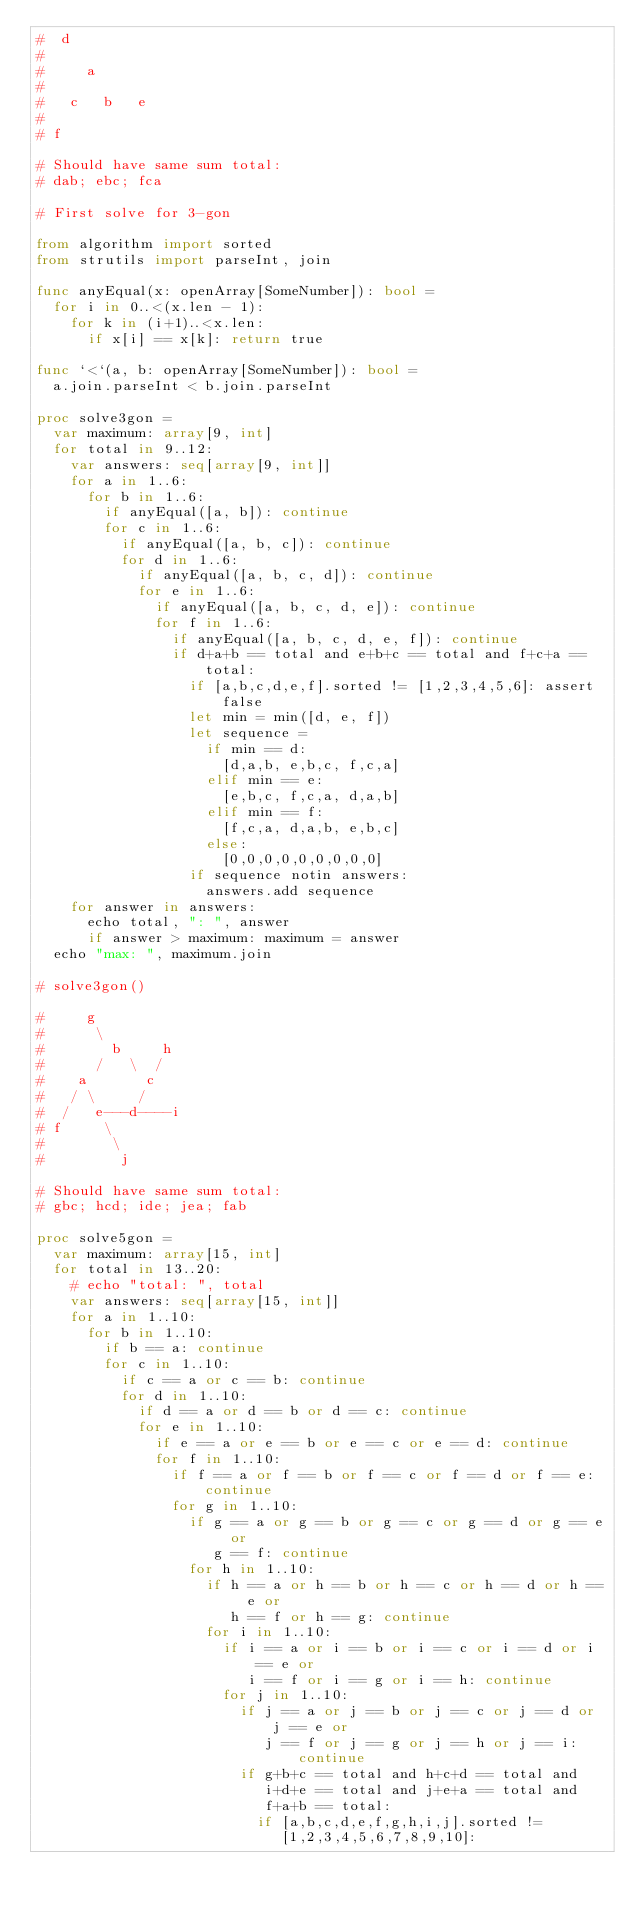<code> <loc_0><loc_0><loc_500><loc_500><_Nim_>#  d
#
#     a
#
#   c   b   e
#
# f

# Should have same sum total:
# dab; ebc; fca

# First solve for 3-gon

from algorithm import sorted
from strutils import parseInt, join

func anyEqual(x: openArray[SomeNumber]): bool =
  for i in 0..<(x.len - 1):
    for k in (i+1)..<x.len:
      if x[i] == x[k]: return true

func `<`(a, b: openArray[SomeNumber]): bool =
  a.join.parseInt < b.join.parseInt

proc solve3gon =
  var maximum: array[9, int]
  for total in 9..12:
    var answers: seq[array[9, int]]
    for a in 1..6:
      for b in 1..6:
        if anyEqual([a, b]): continue
        for c in 1..6:
          if anyEqual([a, b, c]): continue
          for d in 1..6:
            if anyEqual([a, b, c, d]): continue
            for e in 1..6:
              if anyEqual([a, b, c, d, e]): continue
              for f in 1..6:
                if anyEqual([a, b, c, d, e, f]): continue
                if d+a+b == total and e+b+c == total and f+c+a == total:
                  if [a,b,c,d,e,f].sorted != [1,2,3,4,5,6]: assert false
                  let min = min([d, e, f])
                  let sequence =
                    if min == d:
                      [d,a,b, e,b,c, f,c,a]
                    elif min == e:
                      [e,b,c, f,c,a, d,a,b]
                    elif min == f:
                      [f,c,a, d,a,b, e,b,c]
                    else:
                      [0,0,0,0,0,0,0,0,0]
                  if sequence notin answers:
                    answers.add sequence
    for answer in answers:
      echo total, ": ", answer
      if answer > maximum: maximum = answer
  echo "max: ", maximum.join

# solve3gon()

#     g
#      \
#        b     h
#      /   \  /
#    a       c
#   / \     /
#  /   e---d----i
# f     \
#        \
#         j

# Should have same sum total:
# gbc; hcd; ide; jea; fab

proc solve5gon =
  var maximum: array[15, int]
  for total in 13..20:
    # echo "total: ", total
    var answers: seq[array[15, int]]
    for a in 1..10:
      for b in 1..10:
        if b == a: continue
        for c in 1..10:
          if c == a or c == b: continue
          for d in 1..10:
            if d == a or d == b or d == c: continue
            for e in 1..10:
              if e == a or e == b or e == c or e == d: continue
              for f in 1..10:
                if f == a or f == b or f == c or f == d or f == e: continue
                for g in 1..10:
                  if g == a or g == b or g == c or g == d or g == e or
                     g == f: continue
                  for h in 1..10:
                    if h == a or h == b or h == c or h == d or h == e or
                       h == f or h == g: continue
                    for i in 1..10:
                      if i == a or i == b or i == c or i == d or i == e or
                         i == f or i == g or i == h: continue
                      for j in 1..10:
                        if j == a or j == b or j == c or j == d or j == e or
                           j == f or j == g or j == h or j == i: continue
                        if g+b+c == total and h+c+d == total and
                           i+d+e == total and j+e+a == total and
                           f+a+b == total:
                          if [a,b,c,d,e,f,g,h,i,j].sorted !=
                             [1,2,3,4,5,6,7,8,9,10]:</code> 